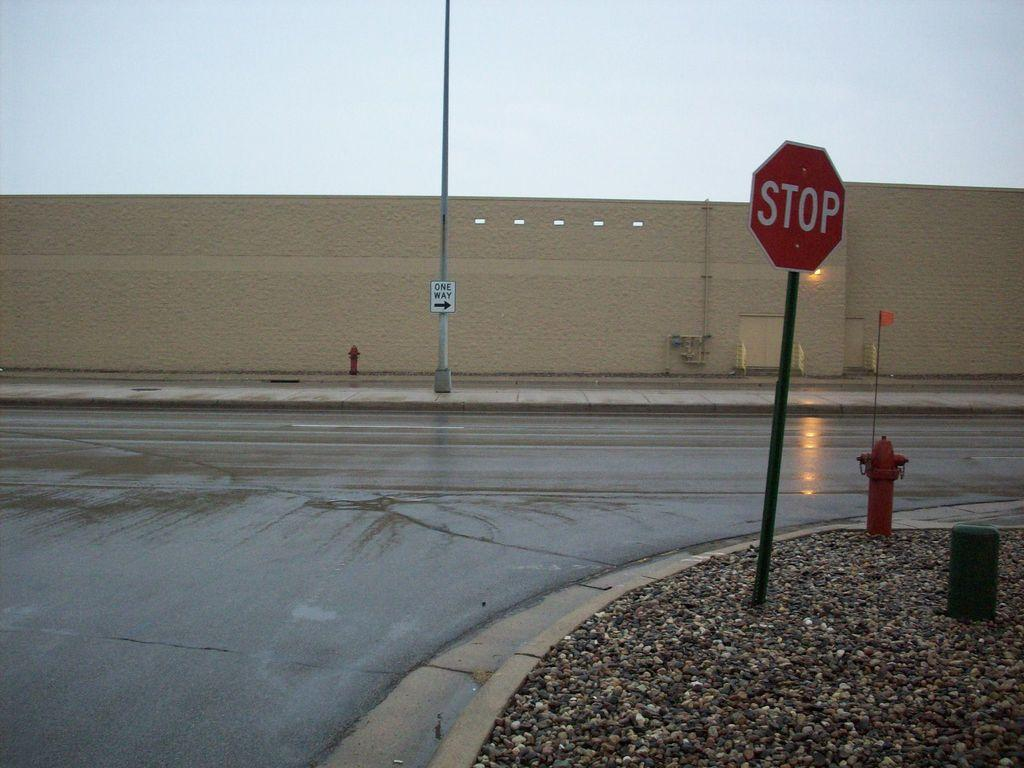Provide a one-sentence caption for the provided image. A red STOP sign stands at a street corner next to a fire hydrant. 